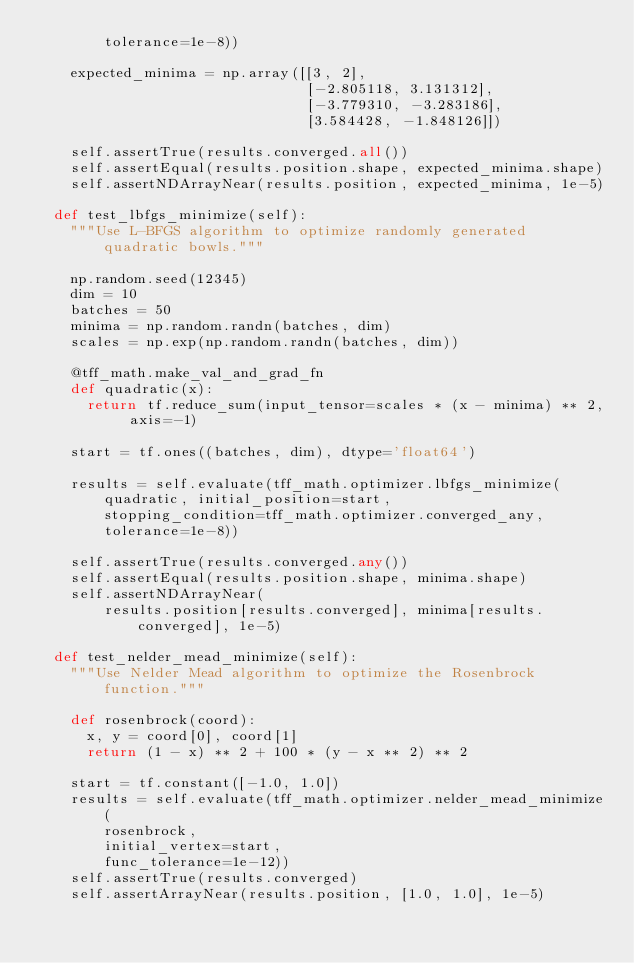Convert code to text. <code><loc_0><loc_0><loc_500><loc_500><_Python_>        tolerance=1e-8))

    expected_minima = np.array([[3, 2],
                                [-2.805118, 3.131312],
                                [-3.779310, -3.283186],
                                [3.584428, -1.848126]])

    self.assertTrue(results.converged.all())
    self.assertEqual(results.position.shape, expected_minima.shape)
    self.assertNDArrayNear(results.position, expected_minima, 1e-5)

  def test_lbfgs_minimize(self):
    """Use L-BFGS algorithm to optimize randomly generated quadratic bowls."""

    np.random.seed(12345)
    dim = 10
    batches = 50
    minima = np.random.randn(batches, dim)
    scales = np.exp(np.random.randn(batches, dim))

    @tff_math.make_val_and_grad_fn
    def quadratic(x):
      return tf.reduce_sum(input_tensor=scales * (x - minima) ** 2, axis=-1)

    start = tf.ones((batches, dim), dtype='float64')

    results = self.evaluate(tff_math.optimizer.lbfgs_minimize(
        quadratic, initial_position=start,
        stopping_condition=tff_math.optimizer.converged_any,
        tolerance=1e-8))

    self.assertTrue(results.converged.any())
    self.assertEqual(results.position.shape, minima.shape)
    self.assertNDArrayNear(
        results.position[results.converged], minima[results.converged], 1e-5)

  def test_nelder_mead_minimize(self):
    """Use Nelder Mead algorithm to optimize the Rosenbrock function."""

    def rosenbrock(coord):
      x, y = coord[0], coord[1]
      return (1 - x) ** 2 + 100 * (y - x ** 2) ** 2

    start = tf.constant([-1.0, 1.0])
    results = self.evaluate(tff_math.optimizer.nelder_mead_minimize(
        rosenbrock,
        initial_vertex=start,
        func_tolerance=1e-12))
    self.assertTrue(results.converged)
    self.assertArrayNear(results.position, [1.0, 1.0], 1e-5)
</code> 